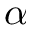Convert formula to latex. <formula><loc_0><loc_0><loc_500><loc_500>\alpha</formula> 